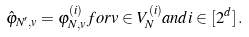Convert formula to latex. <formula><loc_0><loc_0><loc_500><loc_500>\hat { \varphi } _ { N ^ { \prime } , v } = \varphi _ { N , v } ^ { ( i ) } f o r v \in V _ { N } ^ { ( i ) } a n d i \in [ 2 ^ { d } ] \, .</formula> 